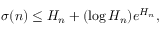<formula> <loc_0><loc_0><loc_500><loc_500>\sigma ( n ) \leq H _ { n } + ( \log H _ { n } ) e ^ { H _ { n } } ,</formula> 